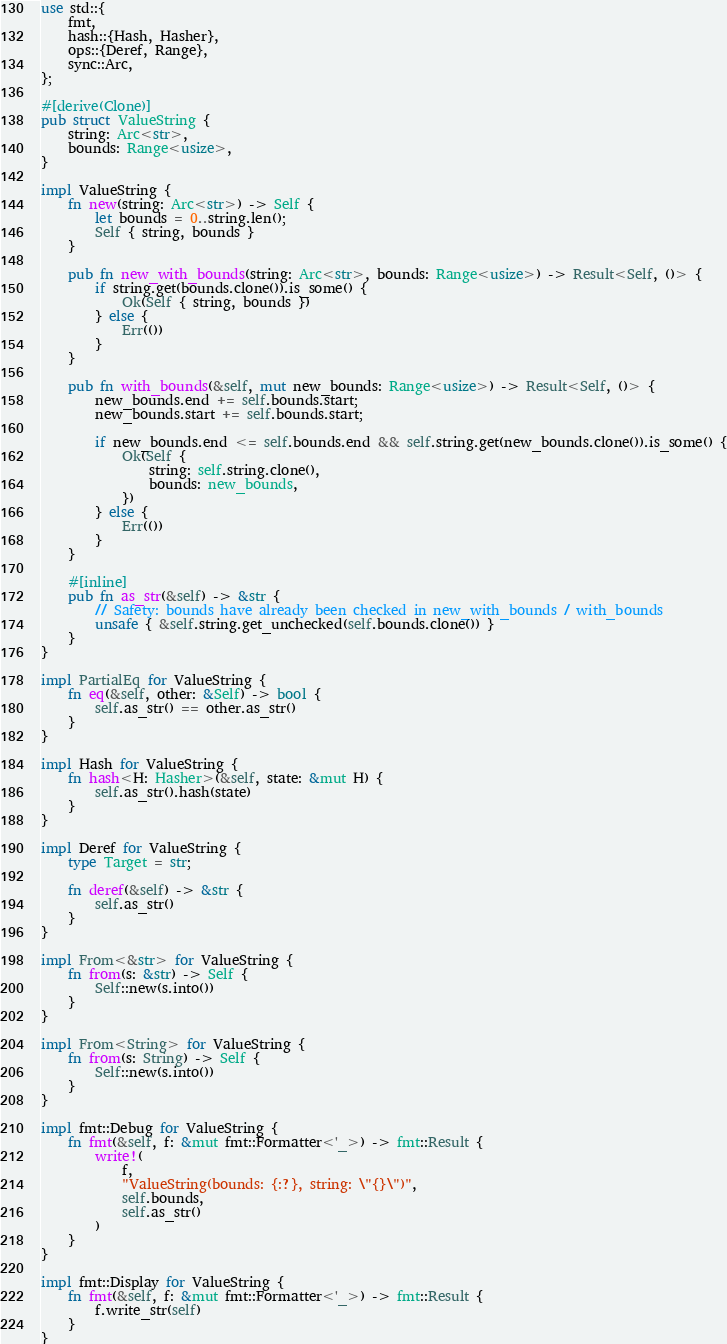<code> <loc_0><loc_0><loc_500><loc_500><_Rust_>use std::{
    fmt,
    hash::{Hash, Hasher},
    ops::{Deref, Range},
    sync::Arc,
};

#[derive(Clone)]
pub struct ValueString {
    string: Arc<str>,
    bounds: Range<usize>,
}

impl ValueString {
    fn new(string: Arc<str>) -> Self {
        let bounds = 0..string.len();
        Self { string, bounds }
    }

    pub fn new_with_bounds(string: Arc<str>, bounds: Range<usize>) -> Result<Self, ()> {
        if string.get(bounds.clone()).is_some() {
            Ok(Self { string, bounds })
        } else {
            Err(())
        }
    }

    pub fn with_bounds(&self, mut new_bounds: Range<usize>) -> Result<Self, ()> {
        new_bounds.end += self.bounds.start;
        new_bounds.start += self.bounds.start;

        if new_bounds.end <= self.bounds.end && self.string.get(new_bounds.clone()).is_some() {
            Ok(Self {
                string: self.string.clone(),
                bounds: new_bounds,
            })
        } else {
            Err(())
        }
    }

    #[inline]
    pub fn as_str(&self) -> &str {
        // Safety: bounds have already been checked in new_with_bounds / with_bounds
        unsafe { &self.string.get_unchecked(self.bounds.clone()) }
    }
}

impl PartialEq for ValueString {
    fn eq(&self, other: &Self) -> bool {
        self.as_str() == other.as_str()
    }
}

impl Hash for ValueString {
    fn hash<H: Hasher>(&self, state: &mut H) {
        self.as_str().hash(state)
    }
}

impl Deref for ValueString {
    type Target = str;

    fn deref(&self) -> &str {
        self.as_str()
    }
}

impl From<&str> for ValueString {
    fn from(s: &str) -> Self {
        Self::new(s.into())
    }
}

impl From<String> for ValueString {
    fn from(s: String) -> Self {
        Self::new(s.into())
    }
}

impl fmt::Debug for ValueString {
    fn fmt(&self, f: &mut fmt::Formatter<'_>) -> fmt::Result {
        write!(
            f,
            "ValueString(bounds: {:?}, string: \"{}\")",
            self.bounds,
            self.as_str()
        )
    }
}

impl fmt::Display for ValueString {
    fn fmt(&self, f: &mut fmt::Formatter<'_>) -> fmt::Result {
        f.write_str(self)
    }
}
</code> 